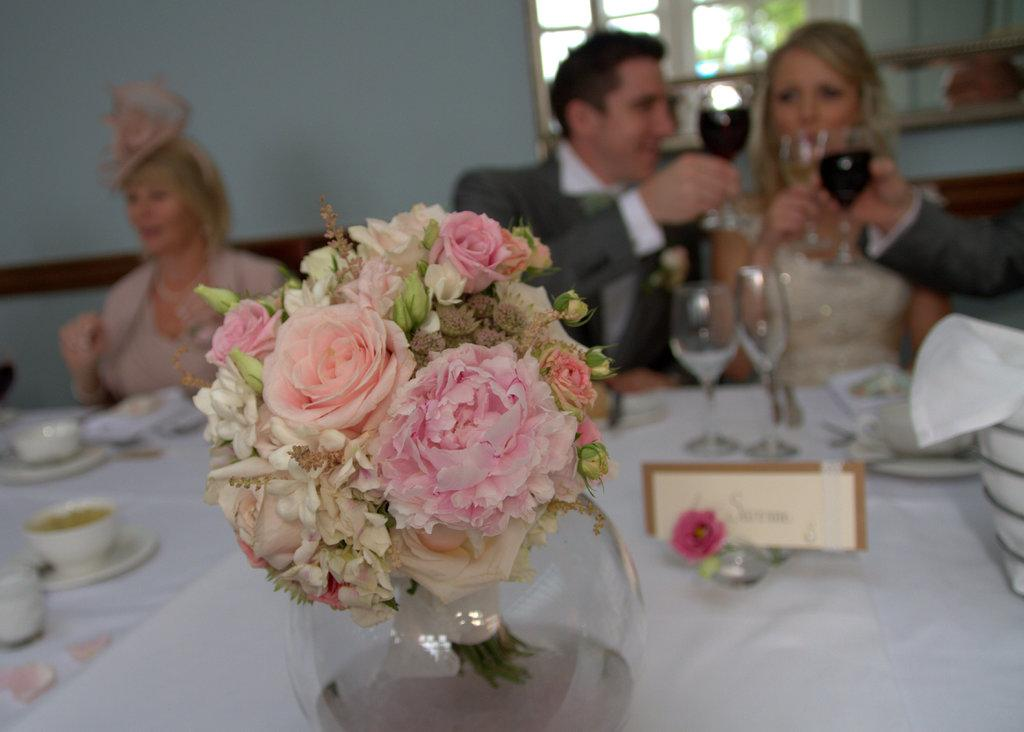What is on the table in the image? There are flowers on the table. What is the person at the table doing? The person is sitting at the table. How is the food being served in the image? The food is served on plates. What type of glasses are present on the table? There are wine glasses present. What type of tent can be seen in the background of the image? There is no tent present in the image. How many nails are used to hold the table together in the image? There is no information about the construction of the table in the image, so we cannot determine the number of nails used. 